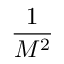<formula> <loc_0><loc_0><loc_500><loc_500>\frac { 1 } { M ^ { 2 } }</formula> 